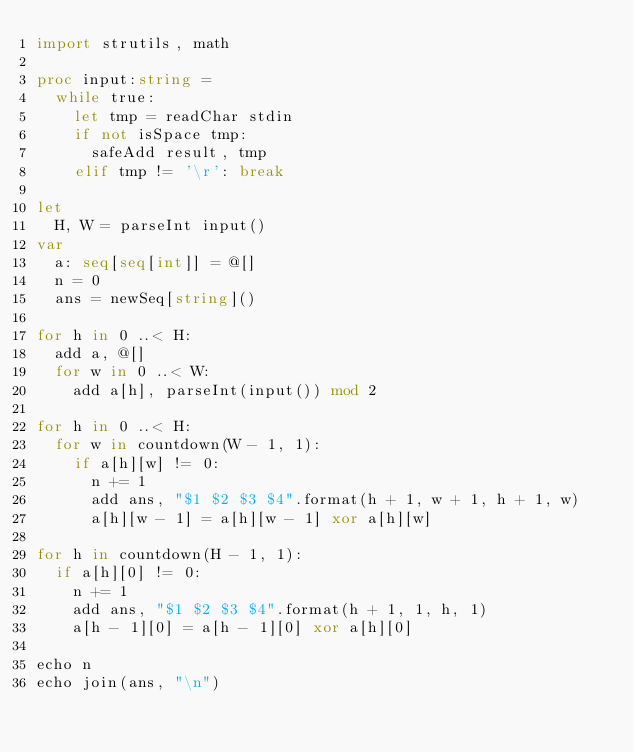Convert code to text. <code><loc_0><loc_0><loc_500><loc_500><_Nim_>import strutils, math

proc input:string =
  while true:
    let tmp = readChar stdin
    if not isSpace tmp:
      safeAdd result, tmp
    elif tmp != '\r': break

let
  H, W = parseInt input()
var
  a: seq[seq[int]] = @[]
  n = 0
  ans = newSeq[string]()

for h in 0 ..< H:
  add a, @[]
  for w in 0 ..< W:
    add a[h], parseInt(input()) mod 2

for h in 0 ..< H:
  for w in countdown(W - 1, 1):
    if a[h][w] != 0:
      n += 1
      add ans, "$1 $2 $3 $4".format(h + 1, w + 1, h + 1, w)
      a[h][w - 1] = a[h][w - 1] xor a[h][w]

for h in countdown(H - 1, 1):
  if a[h][0] != 0:
    n += 1
    add ans, "$1 $2 $3 $4".format(h + 1, 1, h, 1)
    a[h - 1][0] = a[h - 1][0] xor a[h][0]

echo n
echo join(ans, "\n")
</code> 